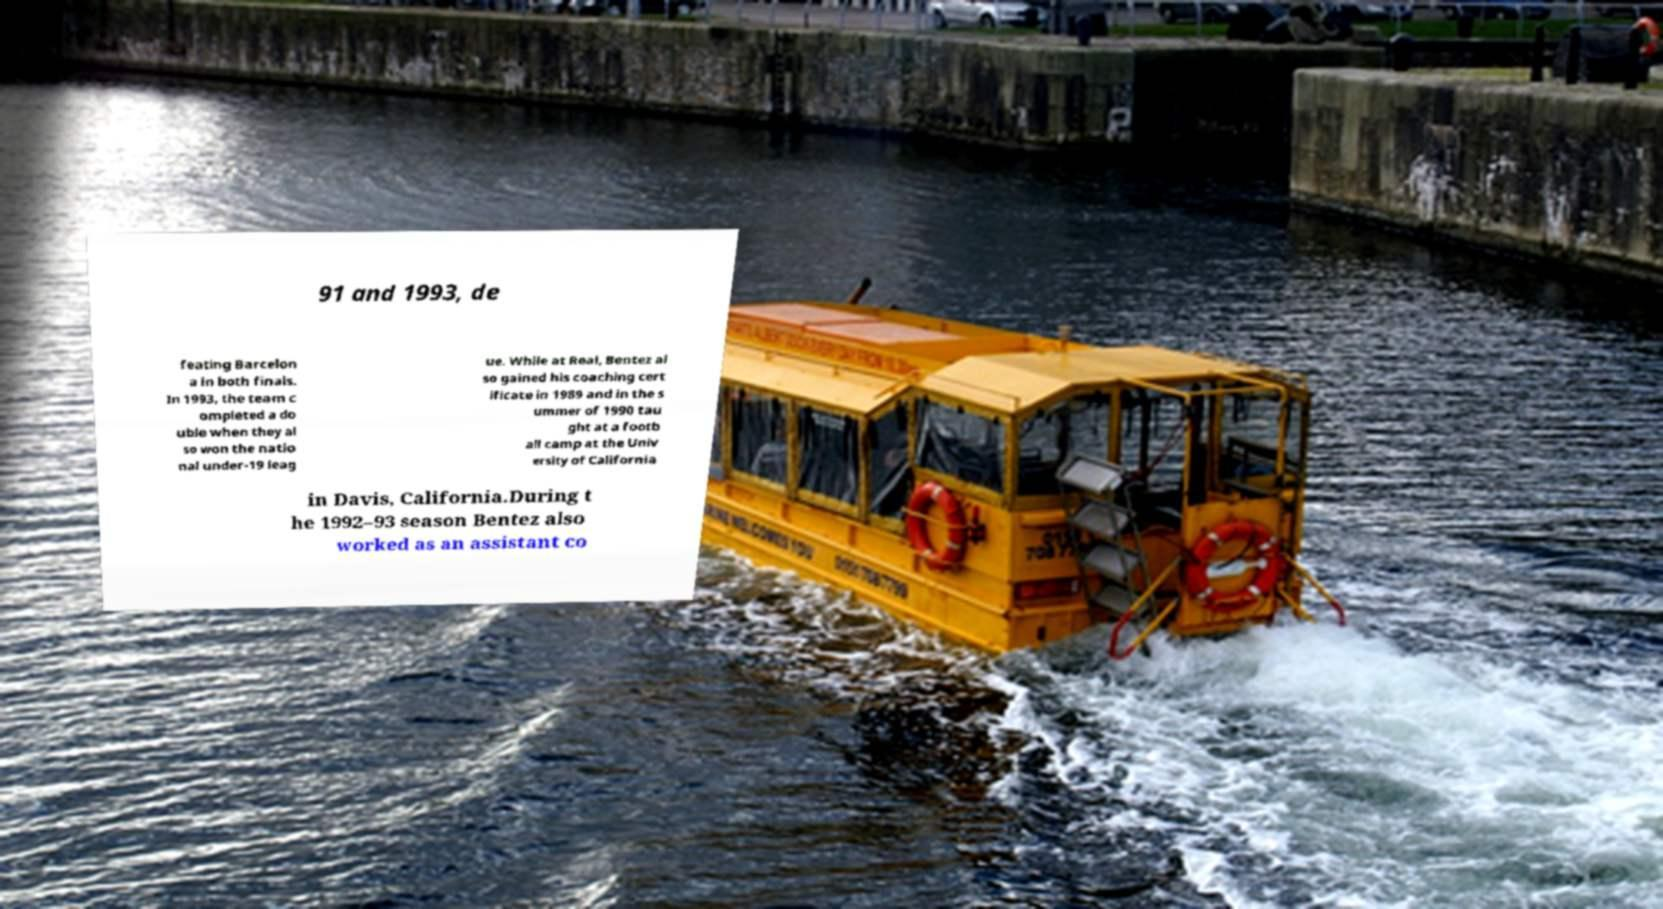There's text embedded in this image that I need extracted. Can you transcribe it verbatim? 91 and 1993, de feating Barcelon a in both finals. In 1993, the team c ompleted a do uble when they al so won the natio nal under-19 leag ue. While at Real, Bentez al so gained his coaching cert ificate in 1989 and in the s ummer of 1990 tau ght at a footb all camp at the Univ ersity of California in Davis, California.During t he 1992–93 season Bentez also worked as an assistant co 